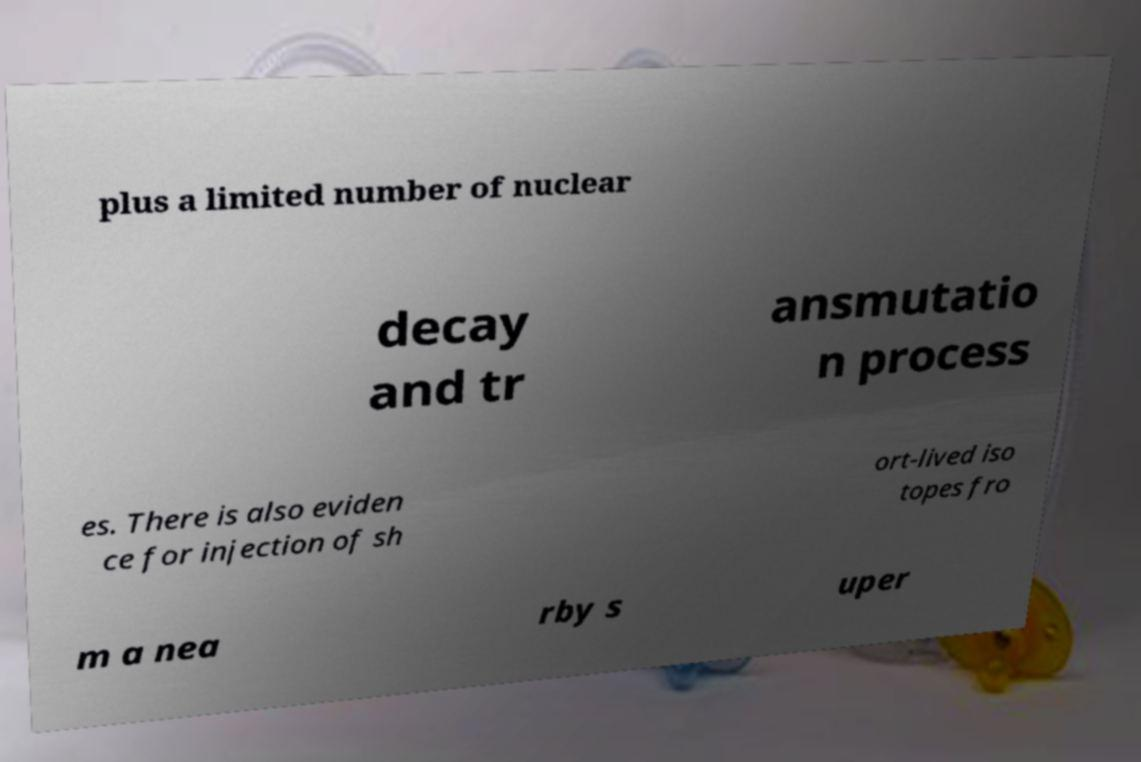There's text embedded in this image that I need extracted. Can you transcribe it verbatim? plus a limited number of nuclear decay and tr ansmutatio n process es. There is also eviden ce for injection of sh ort-lived iso topes fro m a nea rby s uper 